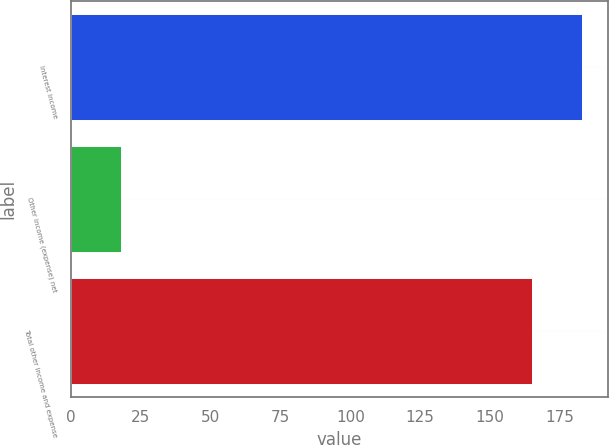Convert chart to OTSL. <chart><loc_0><loc_0><loc_500><loc_500><bar_chart><fcel>Interest income<fcel>Other income (expense) net<fcel>Total other income and expense<nl><fcel>183<fcel>18<fcel>165<nl></chart> 